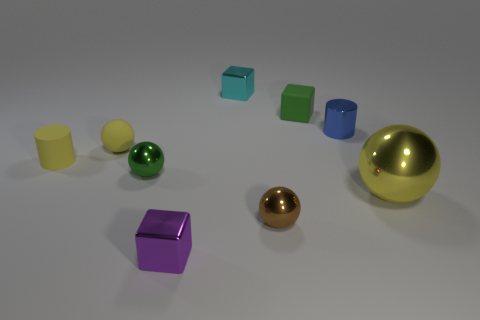Subtract all shiny cubes. How many cubes are left? 1 Subtract all red cylinders. How many red spheres are left? 0 Subtract all small metal cylinders. Subtract all yellow cylinders. How many objects are left? 7 Add 7 large yellow shiny spheres. How many large yellow shiny spheres are left? 8 Add 3 metal cylinders. How many metal cylinders exist? 4 Subtract all purple cubes. How many cubes are left? 2 Subtract 1 green balls. How many objects are left? 8 Subtract all blocks. How many objects are left? 6 Subtract 2 cylinders. How many cylinders are left? 0 Subtract all purple balls. Subtract all gray cylinders. How many balls are left? 4 